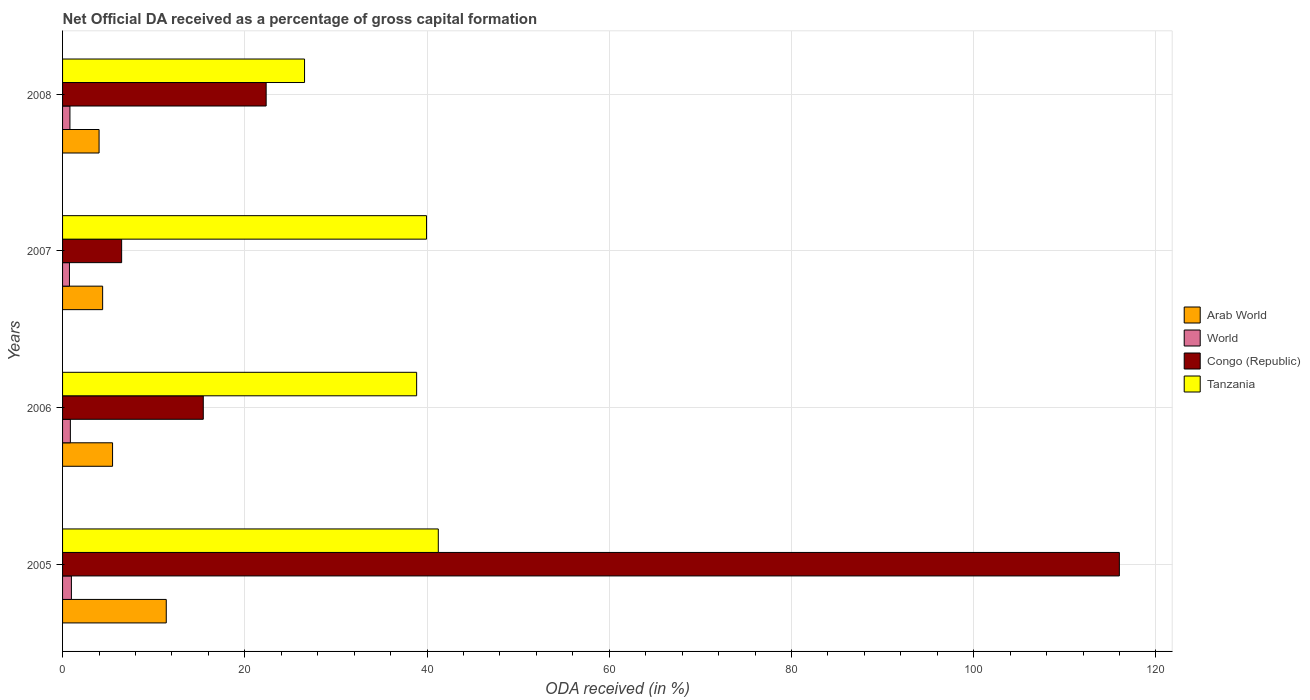How many groups of bars are there?
Make the answer very short. 4. Are the number of bars per tick equal to the number of legend labels?
Give a very brief answer. Yes. How many bars are there on the 2nd tick from the top?
Your answer should be very brief. 4. In how many cases, is the number of bars for a given year not equal to the number of legend labels?
Your answer should be very brief. 0. What is the net ODA received in Arab World in 2007?
Provide a succinct answer. 4.4. Across all years, what is the maximum net ODA received in World?
Make the answer very short. 0.97. Across all years, what is the minimum net ODA received in Congo (Republic)?
Provide a short and direct response. 6.48. In which year was the net ODA received in Arab World maximum?
Your answer should be very brief. 2005. What is the total net ODA received in Arab World in the graph?
Your answer should be very brief. 25.28. What is the difference between the net ODA received in Arab World in 2006 and that in 2008?
Your answer should be compact. 1.48. What is the difference between the net ODA received in Tanzania in 2006 and the net ODA received in Arab World in 2008?
Your response must be concise. 34.86. What is the average net ODA received in Congo (Republic) per year?
Give a very brief answer. 40.07. In the year 2006, what is the difference between the net ODA received in Congo (Republic) and net ODA received in World?
Ensure brevity in your answer.  14.59. In how many years, is the net ODA received in Arab World greater than 80 %?
Provide a short and direct response. 0. What is the ratio of the net ODA received in Tanzania in 2006 to that in 2008?
Keep it short and to the point. 1.46. What is the difference between the highest and the second highest net ODA received in Arab World?
Make the answer very short. 5.89. What is the difference between the highest and the lowest net ODA received in Arab World?
Offer a terse response. 7.38. In how many years, is the net ODA received in Congo (Republic) greater than the average net ODA received in Congo (Republic) taken over all years?
Provide a succinct answer. 1. Is it the case that in every year, the sum of the net ODA received in Congo (Republic) and net ODA received in Tanzania is greater than the sum of net ODA received in World and net ODA received in Arab World?
Make the answer very short. Yes. What does the 1st bar from the top in 2005 represents?
Make the answer very short. Tanzania. What does the 3rd bar from the bottom in 2008 represents?
Make the answer very short. Congo (Republic). Is it the case that in every year, the sum of the net ODA received in Tanzania and net ODA received in Arab World is greater than the net ODA received in Congo (Republic)?
Your answer should be compact. No. Does the graph contain any zero values?
Your answer should be very brief. No. Does the graph contain grids?
Your answer should be very brief. Yes. What is the title of the graph?
Provide a succinct answer. Net Official DA received as a percentage of gross capital formation. What is the label or title of the X-axis?
Ensure brevity in your answer.  ODA received (in %). What is the label or title of the Y-axis?
Make the answer very short. Years. What is the ODA received (in %) of Arab World in 2005?
Provide a short and direct response. 11.38. What is the ODA received (in %) in World in 2005?
Your answer should be very brief. 0.97. What is the ODA received (in %) of Congo (Republic) in 2005?
Keep it short and to the point. 115.99. What is the ODA received (in %) of Tanzania in 2005?
Your response must be concise. 41.24. What is the ODA received (in %) in Arab World in 2006?
Ensure brevity in your answer.  5.49. What is the ODA received (in %) of World in 2006?
Offer a very short reply. 0.86. What is the ODA received (in %) of Congo (Republic) in 2006?
Your response must be concise. 15.44. What is the ODA received (in %) in Tanzania in 2006?
Your answer should be compact. 38.86. What is the ODA received (in %) in Arab World in 2007?
Offer a very short reply. 4.4. What is the ODA received (in %) of World in 2007?
Your answer should be compact. 0.76. What is the ODA received (in %) in Congo (Republic) in 2007?
Your answer should be very brief. 6.48. What is the ODA received (in %) of Tanzania in 2007?
Make the answer very short. 39.95. What is the ODA received (in %) of Arab World in 2008?
Provide a succinct answer. 4.01. What is the ODA received (in %) in World in 2008?
Ensure brevity in your answer.  0.81. What is the ODA received (in %) of Congo (Republic) in 2008?
Offer a very short reply. 22.34. What is the ODA received (in %) of Tanzania in 2008?
Your response must be concise. 26.56. Across all years, what is the maximum ODA received (in %) of Arab World?
Provide a short and direct response. 11.38. Across all years, what is the maximum ODA received (in %) of World?
Your answer should be compact. 0.97. Across all years, what is the maximum ODA received (in %) in Congo (Republic)?
Offer a very short reply. 115.99. Across all years, what is the maximum ODA received (in %) in Tanzania?
Give a very brief answer. 41.24. Across all years, what is the minimum ODA received (in %) of Arab World?
Make the answer very short. 4.01. Across all years, what is the minimum ODA received (in %) of World?
Make the answer very short. 0.76. Across all years, what is the minimum ODA received (in %) in Congo (Republic)?
Give a very brief answer. 6.48. Across all years, what is the minimum ODA received (in %) in Tanzania?
Provide a succinct answer. 26.56. What is the total ODA received (in %) of Arab World in the graph?
Make the answer very short. 25.28. What is the total ODA received (in %) of World in the graph?
Provide a short and direct response. 3.39. What is the total ODA received (in %) of Congo (Republic) in the graph?
Provide a succinct answer. 160.26. What is the total ODA received (in %) in Tanzania in the graph?
Give a very brief answer. 146.61. What is the difference between the ODA received (in %) of Arab World in 2005 and that in 2006?
Offer a terse response. 5.89. What is the difference between the ODA received (in %) of World in 2005 and that in 2006?
Give a very brief answer. 0.11. What is the difference between the ODA received (in %) in Congo (Republic) in 2005 and that in 2006?
Your answer should be very brief. 100.54. What is the difference between the ODA received (in %) in Tanzania in 2005 and that in 2006?
Give a very brief answer. 2.38. What is the difference between the ODA received (in %) of Arab World in 2005 and that in 2007?
Your answer should be very brief. 6.98. What is the difference between the ODA received (in %) of World in 2005 and that in 2007?
Provide a short and direct response. 0.21. What is the difference between the ODA received (in %) of Congo (Republic) in 2005 and that in 2007?
Keep it short and to the point. 109.51. What is the difference between the ODA received (in %) of Tanzania in 2005 and that in 2007?
Your answer should be very brief. 1.29. What is the difference between the ODA received (in %) in Arab World in 2005 and that in 2008?
Offer a terse response. 7.38. What is the difference between the ODA received (in %) of World in 2005 and that in 2008?
Your answer should be very brief. 0.16. What is the difference between the ODA received (in %) of Congo (Republic) in 2005 and that in 2008?
Provide a short and direct response. 93.64. What is the difference between the ODA received (in %) of Tanzania in 2005 and that in 2008?
Provide a short and direct response. 14.68. What is the difference between the ODA received (in %) of Arab World in 2006 and that in 2007?
Your answer should be compact. 1.09. What is the difference between the ODA received (in %) of World in 2006 and that in 2007?
Your answer should be compact. 0.1. What is the difference between the ODA received (in %) in Congo (Republic) in 2006 and that in 2007?
Give a very brief answer. 8.96. What is the difference between the ODA received (in %) in Tanzania in 2006 and that in 2007?
Your answer should be compact. -1.09. What is the difference between the ODA received (in %) in Arab World in 2006 and that in 2008?
Make the answer very short. 1.48. What is the difference between the ODA received (in %) of World in 2006 and that in 2008?
Provide a succinct answer. 0.05. What is the difference between the ODA received (in %) in Congo (Republic) in 2006 and that in 2008?
Your answer should be very brief. -6.9. What is the difference between the ODA received (in %) of Tanzania in 2006 and that in 2008?
Your answer should be compact. 12.3. What is the difference between the ODA received (in %) in Arab World in 2007 and that in 2008?
Provide a short and direct response. 0.39. What is the difference between the ODA received (in %) of World in 2007 and that in 2008?
Your answer should be compact. -0.05. What is the difference between the ODA received (in %) in Congo (Republic) in 2007 and that in 2008?
Your answer should be very brief. -15.86. What is the difference between the ODA received (in %) of Tanzania in 2007 and that in 2008?
Keep it short and to the point. 13.39. What is the difference between the ODA received (in %) in Arab World in 2005 and the ODA received (in %) in World in 2006?
Ensure brevity in your answer.  10.52. What is the difference between the ODA received (in %) of Arab World in 2005 and the ODA received (in %) of Congo (Republic) in 2006?
Your answer should be compact. -4.06. What is the difference between the ODA received (in %) of Arab World in 2005 and the ODA received (in %) of Tanzania in 2006?
Offer a very short reply. -27.48. What is the difference between the ODA received (in %) of World in 2005 and the ODA received (in %) of Congo (Republic) in 2006?
Your response must be concise. -14.47. What is the difference between the ODA received (in %) in World in 2005 and the ODA received (in %) in Tanzania in 2006?
Offer a terse response. -37.89. What is the difference between the ODA received (in %) in Congo (Republic) in 2005 and the ODA received (in %) in Tanzania in 2006?
Your answer should be very brief. 77.13. What is the difference between the ODA received (in %) in Arab World in 2005 and the ODA received (in %) in World in 2007?
Provide a short and direct response. 10.63. What is the difference between the ODA received (in %) of Arab World in 2005 and the ODA received (in %) of Congo (Republic) in 2007?
Ensure brevity in your answer.  4.9. What is the difference between the ODA received (in %) in Arab World in 2005 and the ODA received (in %) in Tanzania in 2007?
Provide a succinct answer. -28.57. What is the difference between the ODA received (in %) of World in 2005 and the ODA received (in %) of Congo (Republic) in 2007?
Keep it short and to the point. -5.51. What is the difference between the ODA received (in %) of World in 2005 and the ODA received (in %) of Tanzania in 2007?
Your answer should be very brief. -38.98. What is the difference between the ODA received (in %) in Congo (Republic) in 2005 and the ODA received (in %) in Tanzania in 2007?
Your response must be concise. 76.04. What is the difference between the ODA received (in %) of Arab World in 2005 and the ODA received (in %) of World in 2008?
Provide a succinct answer. 10.57. What is the difference between the ODA received (in %) in Arab World in 2005 and the ODA received (in %) in Congo (Republic) in 2008?
Make the answer very short. -10.96. What is the difference between the ODA received (in %) of Arab World in 2005 and the ODA received (in %) of Tanzania in 2008?
Your answer should be compact. -15.18. What is the difference between the ODA received (in %) in World in 2005 and the ODA received (in %) in Congo (Republic) in 2008?
Make the answer very short. -21.37. What is the difference between the ODA received (in %) of World in 2005 and the ODA received (in %) of Tanzania in 2008?
Keep it short and to the point. -25.59. What is the difference between the ODA received (in %) in Congo (Republic) in 2005 and the ODA received (in %) in Tanzania in 2008?
Your answer should be very brief. 89.43. What is the difference between the ODA received (in %) in Arab World in 2006 and the ODA received (in %) in World in 2007?
Make the answer very short. 4.73. What is the difference between the ODA received (in %) in Arab World in 2006 and the ODA received (in %) in Congo (Republic) in 2007?
Your answer should be very brief. -0.99. What is the difference between the ODA received (in %) in Arab World in 2006 and the ODA received (in %) in Tanzania in 2007?
Your answer should be very brief. -34.46. What is the difference between the ODA received (in %) in World in 2006 and the ODA received (in %) in Congo (Republic) in 2007?
Provide a short and direct response. -5.63. What is the difference between the ODA received (in %) of World in 2006 and the ODA received (in %) of Tanzania in 2007?
Offer a very short reply. -39.09. What is the difference between the ODA received (in %) in Congo (Republic) in 2006 and the ODA received (in %) in Tanzania in 2007?
Provide a succinct answer. -24.5. What is the difference between the ODA received (in %) in Arab World in 2006 and the ODA received (in %) in World in 2008?
Your answer should be compact. 4.68. What is the difference between the ODA received (in %) of Arab World in 2006 and the ODA received (in %) of Congo (Republic) in 2008?
Your response must be concise. -16.86. What is the difference between the ODA received (in %) of Arab World in 2006 and the ODA received (in %) of Tanzania in 2008?
Ensure brevity in your answer.  -21.07. What is the difference between the ODA received (in %) in World in 2006 and the ODA received (in %) in Congo (Republic) in 2008?
Ensure brevity in your answer.  -21.49. What is the difference between the ODA received (in %) in World in 2006 and the ODA received (in %) in Tanzania in 2008?
Your response must be concise. -25.7. What is the difference between the ODA received (in %) of Congo (Republic) in 2006 and the ODA received (in %) of Tanzania in 2008?
Offer a terse response. -11.11. What is the difference between the ODA received (in %) in Arab World in 2007 and the ODA received (in %) in World in 2008?
Offer a terse response. 3.59. What is the difference between the ODA received (in %) in Arab World in 2007 and the ODA received (in %) in Congo (Republic) in 2008?
Offer a very short reply. -17.95. What is the difference between the ODA received (in %) of Arab World in 2007 and the ODA received (in %) of Tanzania in 2008?
Make the answer very short. -22.16. What is the difference between the ODA received (in %) of World in 2007 and the ODA received (in %) of Congo (Republic) in 2008?
Offer a terse response. -21.59. What is the difference between the ODA received (in %) of World in 2007 and the ODA received (in %) of Tanzania in 2008?
Offer a very short reply. -25.8. What is the difference between the ODA received (in %) of Congo (Republic) in 2007 and the ODA received (in %) of Tanzania in 2008?
Offer a terse response. -20.08. What is the average ODA received (in %) of Arab World per year?
Ensure brevity in your answer.  6.32. What is the average ODA received (in %) of World per year?
Make the answer very short. 0.85. What is the average ODA received (in %) of Congo (Republic) per year?
Provide a succinct answer. 40.07. What is the average ODA received (in %) of Tanzania per year?
Your answer should be very brief. 36.65. In the year 2005, what is the difference between the ODA received (in %) in Arab World and ODA received (in %) in World?
Ensure brevity in your answer.  10.41. In the year 2005, what is the difference between the ODA received (in %) in Arab World and ODA received (in %) in Congo (Republic)?
Your answer should be very brief. -104.61. In the year 2005, what is the difference between the ODA received (in %) in Arab World and ODA received (in %) in Tanzania?
Ensure brevity in your answer.  -29.86. In the year 2005, what is the difference between the ODA received (in %) of World and ODA received (in %) of Congo (Republic)?
Provide a succinct answer. -115.02. In the year 2005, what is the difference between the ODA received (in %) in World and ODA received (in %) in Tanzania?
Your response must be concise. -40.27. In the year 2005, what is the difference between the ODA received (in %) in Congo (Republic) and ODA received (in %) in Tanzania?
Ensure brevity in your answer.  74.75. In the year 2006, what is the difference between the ODA received (in %) of Arab World and ODA received (in %) of World?
Give a very brief answer. 4.63. In the year 2006, what is the difference between the ODA received (in %) in Arab World and ODA received (in %) in Congo (Republic)?
Your response must be concise. -9.96. In the year 2006, what is the difference between the ODA received (in %) of Arab World and ODA received (in %) of Tanzania?
Provide a succinct answer. -33.37. In the year 2006, what is the difference between the ODA received (in %) in World and ODA received (in %) in Congo (Republic)?
Keep it short and to the point. -14.59. In the year 2006, what is the difference between the ODA received (in %) of World and ODA received (in %) of Tanzania?
Offer a terse response. -38. In the year 2006, what is the difference between the ODA received (in %) in Congo (Republic) and ODA received (in %) in Tanzania?
Give a very brief answer. -23.42. In the year 2007, what is the difference between the ODA received (in %) of Arab World and ODA received (in %) of World?
Offer a terse response. 3.64. In the year 2007, what is the difference between the ODA received (in %) in Arab World and ODA received (in %) in Congo (Republic)?
Your answer should be very brief. -2.08. In the year 2007, what is the difference between the ODA received (in %) in Arab World and ODA received (in %) in Tanzania?
Offer a terse response. -35.55. In the year 2007, what is the difference between the ODA received (in %) in World and ODA received (in %) in Congo (Republic)?
Your answer should be very brief. -5.73. In the year 2007, what is the difference between the ODA received (in %) in World and ODA received (in %) in Tanzania?
Your response must be concise. -39.19. In the year 2007, what is the difference between the ODA received (in %) of Congo (Republic) and ODA received (in %) of Tanzania?
Keep it short and to the point. -33.46. In the year 2008, what is the difference between the ODA received (in %) of Arab World and ODA received (in %) of World?
Offer a terse response. 3.2. In the year 2008, what is the difference between the ODA received (in %) of Arab World and ODA received (in %) of Congo (Republic)?
Offer a very short reply. -18.34. In the year 2008, what is the difference between the ODA received (in %) of Arab World and ODA received (in %) of Tanzania?
Your answer should be very brief. -22.55. In the year 2008, what is the difference between the ODA received (in %) in World and ODA received (in %) in Congo (Republic)?
Keep it short and to the point. -21.54. In the year 2008, what is the difference between the ODA received (in %) of World and ODA received (in %) of Tanzania?
Your response must be concise. -25.75. In the year 2008, what is the difference between the ODA received (in %) in Congo (Republic) and ODA received (in %) in Tanzania?
Make the answer very short. -4.21. What is the ratio of the ODA received (in %) in Arab World in 2005 to that in 2006?
Offer a terse response. 2.07. What is the ratio of the ODA received (in %) of World in 2005 to that in 2006?
Make the answer very short. 1.13. What is the ratio of the ODA received (in %) of Congo (Republic) in 2005 to that in 2006?
Keep it short and to the point. 7.51. What is the ratio of the ODA received (in %) of Tanzania in 2005 to that in 2006?
Offer a very short reply. 1.06. What is the ratio of the ODA received (in %) in Arab World in 2005 to that in 2007?
Offer a terse response. 2.59. What is the ratio of the ODA received (in %) of World in 2005 to that in 2007?
Your answer should be very brief. 1.28. What is the ratio of the ODA received (in %) of Congo (Republic) in 2005 to that in 2007?
Offer a very short reply. 17.89. What is the ratio of the ODA received (in %) of Tanzania in 2005 to that in 2007?
Give a very brief answer. 1.03. What is the ratio of the ODA received (in %) in Arab World in 2005 to that in 2008?
Provide a succinct answer. 2.84. What is the ratio of the ODA received (in %) in World in 2005 to that in 2008?
Offer a terse response. 1.2. What is the ratio of the ODA received (in %) in Congo (Republic) in 2005 to that in 2008?
Ensure brevity in your answer.  5.19. What is the ratio of the ODA received (in %) in Tanzania in 2005 to that in 2008?
Offer a very short reply. 1.55. What is the ratio of the ODA received (in %) in Arab World in 2006 to that in 2007?
Keep it short and to the point. 1.25. What is the ratio of the ODA received (in %) in World in 2006 to that in 2007?
Provide a short and direct response. 1.14. What is the ratio of the ODA received (in %) of Congo (Republic) in 2006 to that in 2007?
Ensure brevity in your answer.  2.38. What is the ratio of the ODA received (in %) in Tanzania in 2006 to that in 2007?
Ensure brevity in your answer.  0.97. What is the ratio of the ODA received (in %) of Arab World in 2006 to that in 2008?
Make the answer very short. 1.37. What is the ratio of the ODA received (in %) in World in 2006 to that in 2008?
Your answer should be very brief. 1.06. What is the ratio of the ODA received (in %) of Congo (Republic) in 2006 to that in 2008?
Provide a succinct answer. 0.69. What is the ratio of the ODA received (in %) in Tanzania in 2006 to that in 2008?
Ensure brevity in your answer.  1.46. What is the ratio of the ODA received (in %) in Arab World in 2007 to that in 2008?
Offer a terse response. 1.1. What is the ratio of the ODA received (in %) in World in 2007 to that in 2008?
Offer a terse response. 0.93. What is the ratio of the ODA received (in %) of Congo (Republic) in 2007 to that in 2008?
Give a very brief answer. 0.29. What is the ratio of the ODA received (in %) of Tanzania in 2007 to that in 2008?
Offer a very short reply. 1.5. What is the difference between the highest and the second highest ODA received (in %) in Arab World?
Your answer should be compact. 5.89. What is the difference between the highest and the second highest ODA received (in %) of World?
Your response must be concise. 0.11. What is the difference between the highest and the second highest ODA received (in %) in Congo (Republic)?
Provide a short and direct response. 93.64. What is the difference between the highest and the second highest ODA received (in %) of Tanzania?
Offer a very short reply. 1.29. What is the difference between the highest and the lowest ODA received (in %) of Arab World?
Provide a succinct answer. 7.38. What is the difference between the highest and the lowest ODA received (in %) in World?
Offer a very short reply. 0.21. What is the difference between the highest and the lowest ODA received (in %) in Congo (Republic)?
Give a very brief answer. 109.51. What is the difference between the highest and the lowest ODA received (in %) in Tanzania?
Your response must be concise. 14.68. 